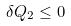Convert formula to latex. <formula><loc_0><loc_0><loc_500><loc_500>\delta Q _ { 2 } \leq 0</formula> 